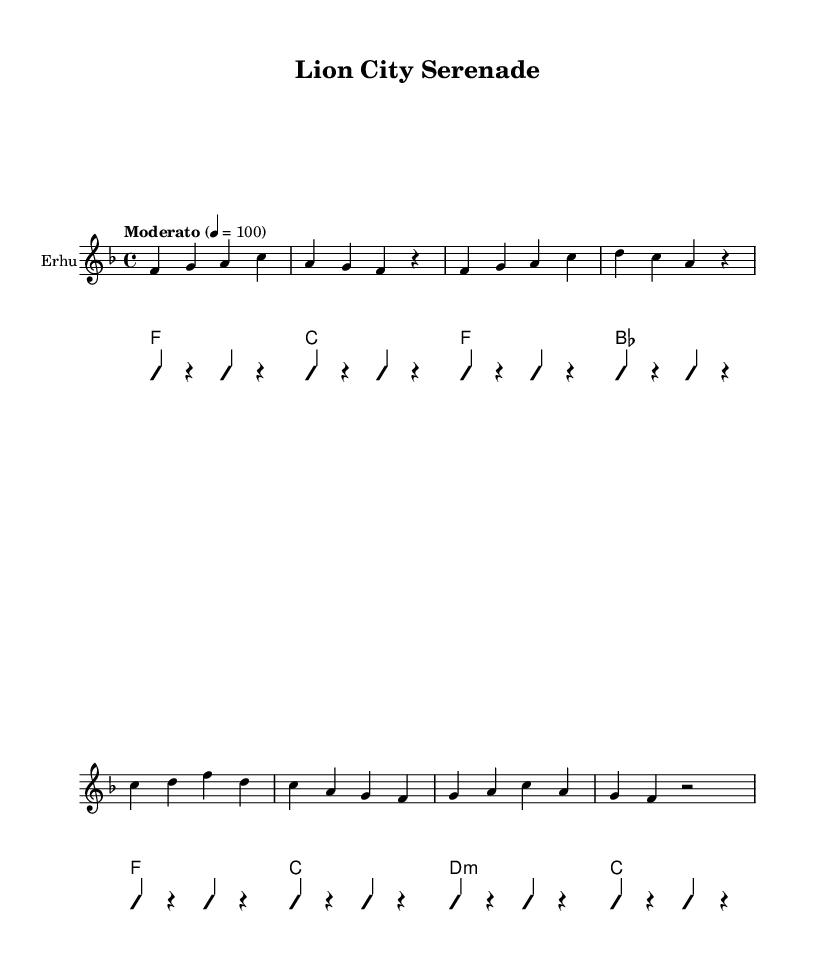What is the title of this piece? The title is explicitly mentioned in the header section of the sheet music. It reads "Lion City Serenade."
Answer: Lion City Serenade What is the key signature of this music? The key signature is indicated at the beginning of the staff. Here, it has one flat, which is characteristic of F major.
Answer: F major What is the time signature of this piece? The time signature is shown after the key signature, represented by the two numbers, which are 4 over 4. This indicates a common time signature often used in music.
Answer: 4/4 What is the tempo marking given for this piece? The tempo marking is located at the beginning near the time signature, stating "Moderato" with a metronome marking of 4 = 100, suggesting a moderate pace for the music.
Answer: Moderato How many measures are in the main melody? By counting the individual groupings in the staff notation, there are a total of 8 measures that make up the main melody, as indicated by the structure of the notes.
Answer: 8 What are the first four notes of the melody? The first four notes in the melody can be found at the start of the staff; they are f, g, a, and c. These notes are critical as they set the foundation for the piece.
Answer: f, g, a, c What cultural elements does the lyrics reflect? The lyrics celebrate Singapore's identity, mentioning the "Merlion," "Garden city," and "cultures blending," highlighting aspects of local culture and heritage significant to Singapore.
Answer: Local culture and heritage 